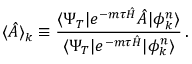Convert formula to latex. <formula><loc_0><loc_0><loc_500><loc_500>\langle \hat { A } \rangle _ { k } \equiv \frac { \langle \Psi _ { T } | e ^ { - m \tau \hat { H } } \hat { A } | \phi _ { k } ^ { n } \rangle } { \langle \Psi _ { T } | e ^ { - m \tau \hat { H } } | \phi _ { k } ^ { n } \rangle } \, .</formula> 